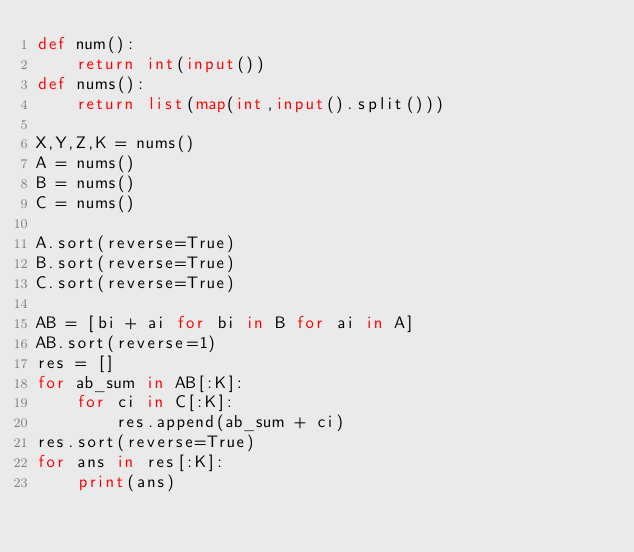<code> <loc_0><loc_0><loc_500><loc_500><_Python_>def num():
    return int(input())
def nums():
    return list(map(int,input().split()))

X,Y,Z,K = nums()
A = nums()
B = nums()
C = nums()

A.sort(reverse=True)
B.sort(reverse=True)
C.sort(reverse=True)

AB = [bi + ai for bi in B for ai in A]
AB.sort(reverse=1)
res = []
for ab_sum in AB[:K]:
    for ci in C[:K]:
        res.append(ab_sum + ci)
res.sort(reverse=True)
for ans in res[:K]:
    print(ans)</code> 